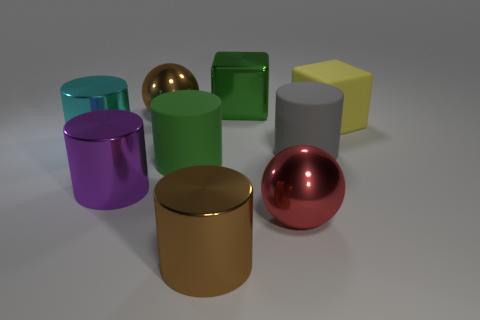There is a large cylinder that is the same color as the metallic block; what is its material?
Your response must be concise. Rubber. What is the material of the green object that is the same shape as the large cyan object?
Make the answer very short. Rubber. Is there any other thing that has the same size as the red sphere?
Ensure brevity in your answer.  Yes. Does the green object in front of the brown sphere have the same shape as the big brown metal thing behind the large matte cube?
Make the answer very short. No. Are there fewer large matte cylinders behind the large brown metal cylinder than matte objects that are in front of the red sphere?
Keep it short and to the point. No. What number of other things are there of the same shape as the large red thing?
Give a very brief answer. 1. What shape is the large purple object that is made of the same material as the red thing?
Your answer should be compact. Cylinder. The cylinder that is both left of the green rubber thing and behind the big purple object is what color?
Provide a short and direct response. Cyan. Are the yellow object behind the large green cylinder and the green cube made of the same material?
Your response must be concise. No. Is the number of big matte objects that are left of the big green cube less than the number of large purple cubes?
Offer a terse response. No. 